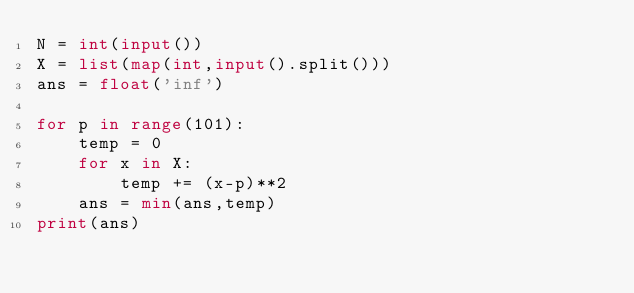Convert code to text. <code><loc_0><loc_0><loc_500><loc_500><_Python_>N = int(input())
X = list(map(int,input().split()))
ans = float('inf')

for p in range(101):
    temp = 0
    for x in X:
        temp += (x-p)**2
    ans = min(ans,temp)
print(ans)
</code> 